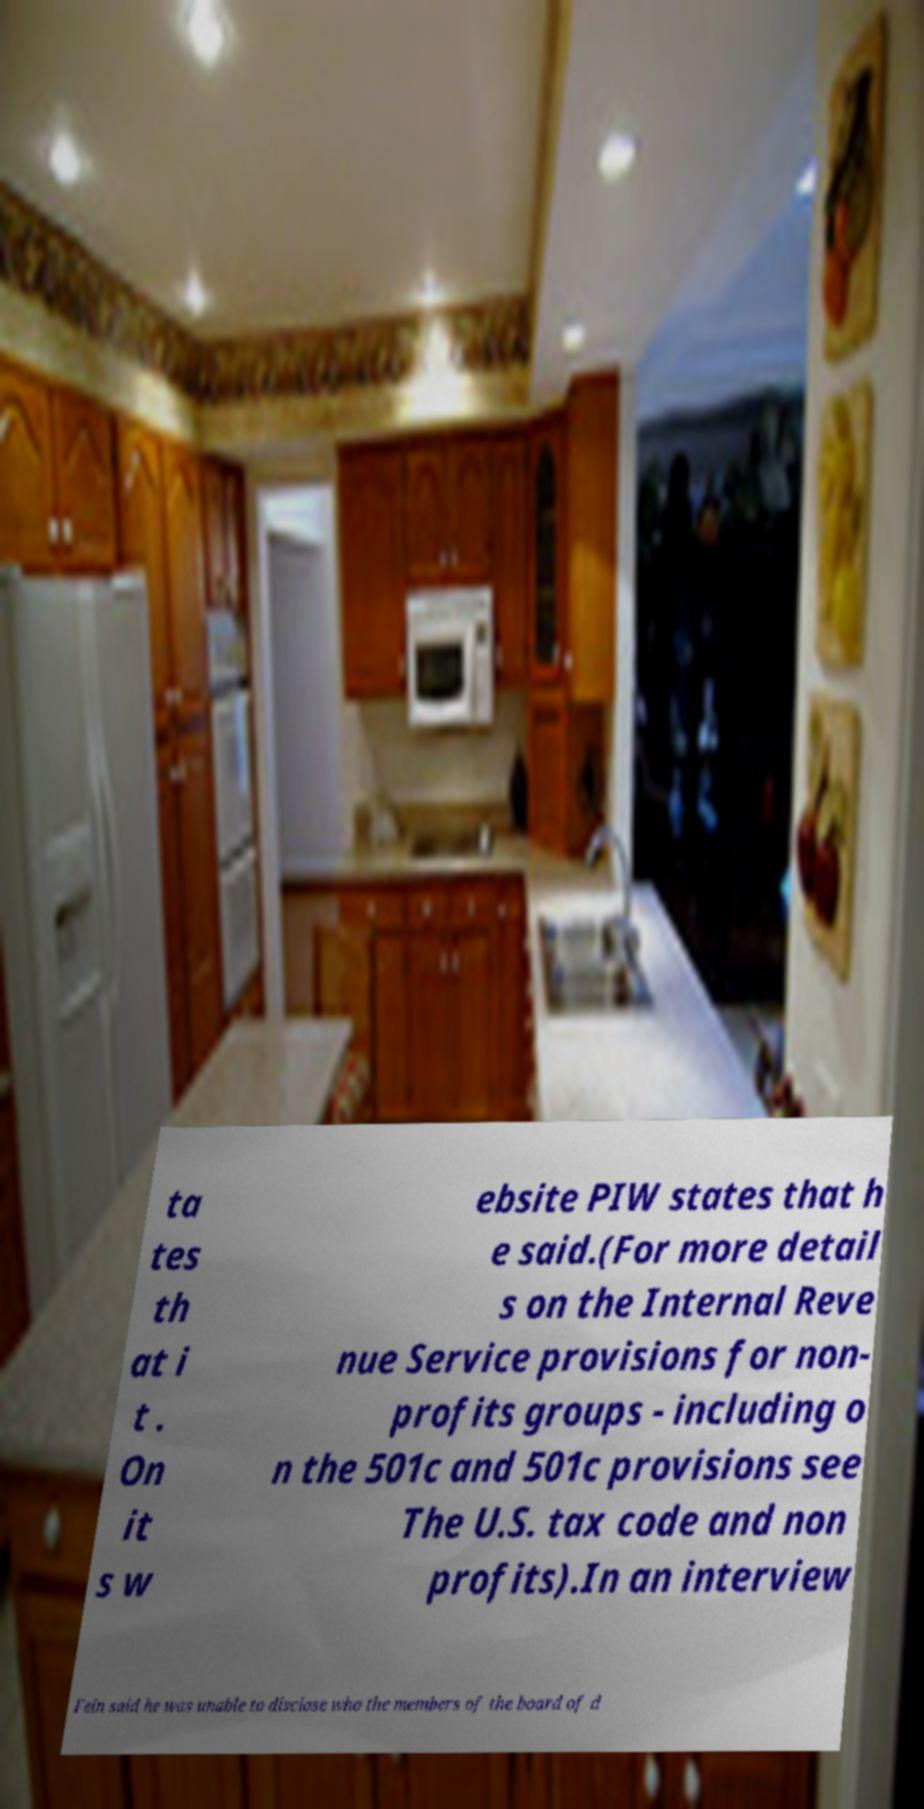I need the written content from this picture converted into text. Can you do that? ta tes th at i t . On it s w ebsite PIW states that h e said.(For more detail s on the Internal Reve nue Service provisions for non- profits groups - including o n the 501c and 501c provisions see The U.S. tax code and non profits).In an interview Fein said he was unable to disclose who the members of the board of d 